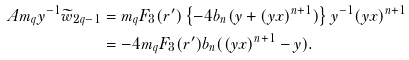<formula> <loc_0><loc_0><loc_500><loc_500>A m _ { q } y ^ { - 1 } \widetilde { w } _ { 2 q - 1 } & = m _ { q } F _ { 3 } ( r ^ { \prime } ) \left \{ - 4 b _ { n } ( y + ( y x ) ^ { n + 1 } ) \right \} y ^ { - 1 } ( y x ) ^ { n + 1 } \\ & = - 4 m _ { q } F _ { 3 } ( r ^ { \prime } ) b _ { n } ( ( y x ) ^ { n + 1 } - y ) .</formula> 